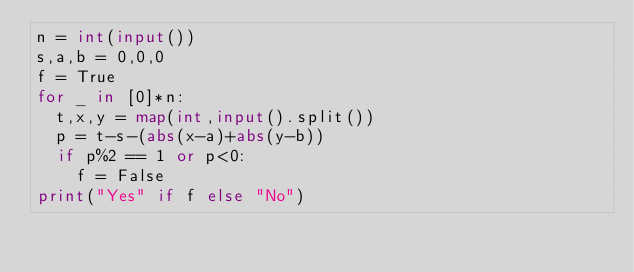Convert code to text. <code><loc_0><loc_0><loc_500><loc_500><_Python_>n = int(input())
s,a,b = 0,0,0
f = True
for _ in [0]*n:
  t,x,y = map(int,input().split())
  p = t-s-(abs(x-a)+abs(y-b))
  if p%2 == 1 or p<0:
    f = False
print("Yes" if f else "No")</code> 